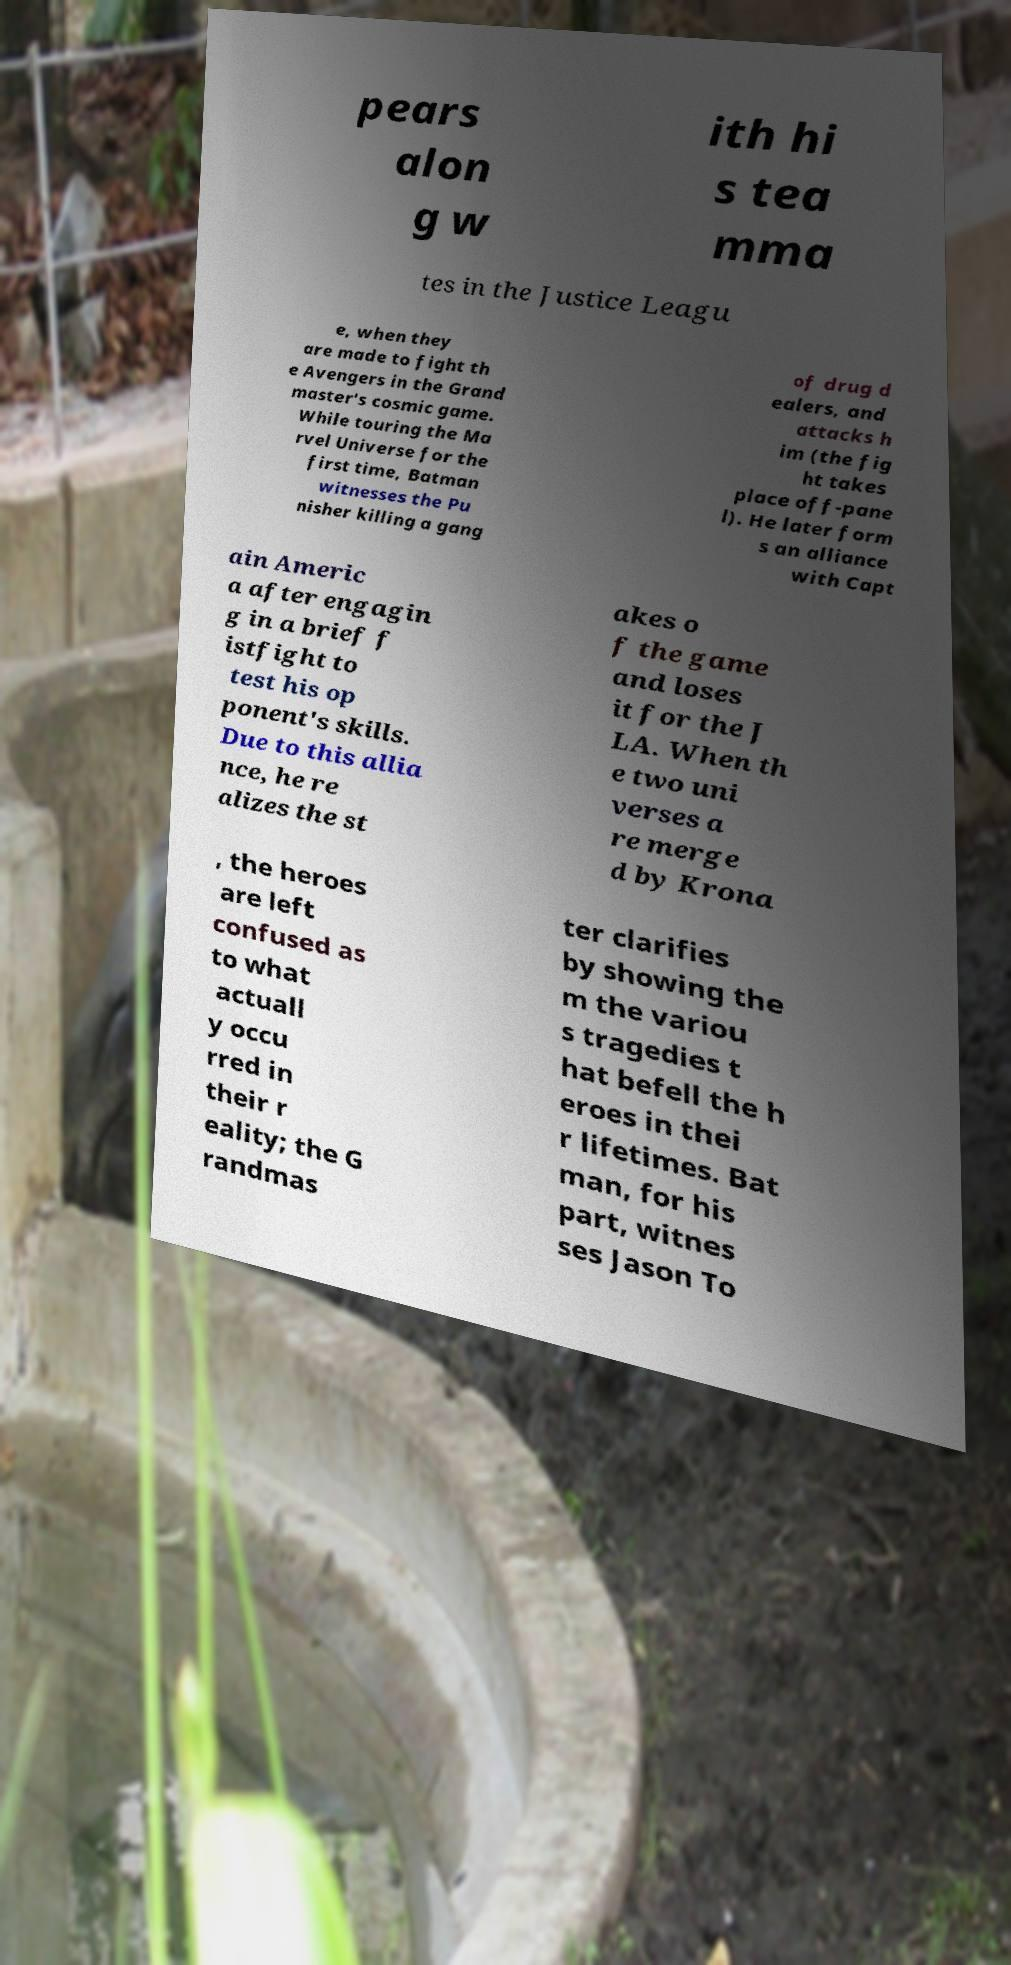I need the written content from this picture converted into text. Can you do that? pears alon g w ith hi s tea mma tes in the Justice Leagu e, when they are made to fight th e Avengers in the Grand master's cosmic game. While touring the Ma rvel Universe for the first time, Batman witnesses the Pu nisher killing a gang of drug d ealers, and attacks h im (the fig ht takes place off-pane l). He later form s an alliance with Capt ain Americ a after engagin g in a brief f istfight to test his op ponent's skills. Due to this allia nce, he re alizes the st akes o f the game and loses it for the J LA. When th e two uni verses a re merge d by Krona , the heroes are left confused as to what actuall y occu rred in their r eality; the G randmas ter clarifies by showing the m the variou s tragedies t hat befell the h eroes in thei r lifetimes. Bat man, for his part, witnes ses Jason To 